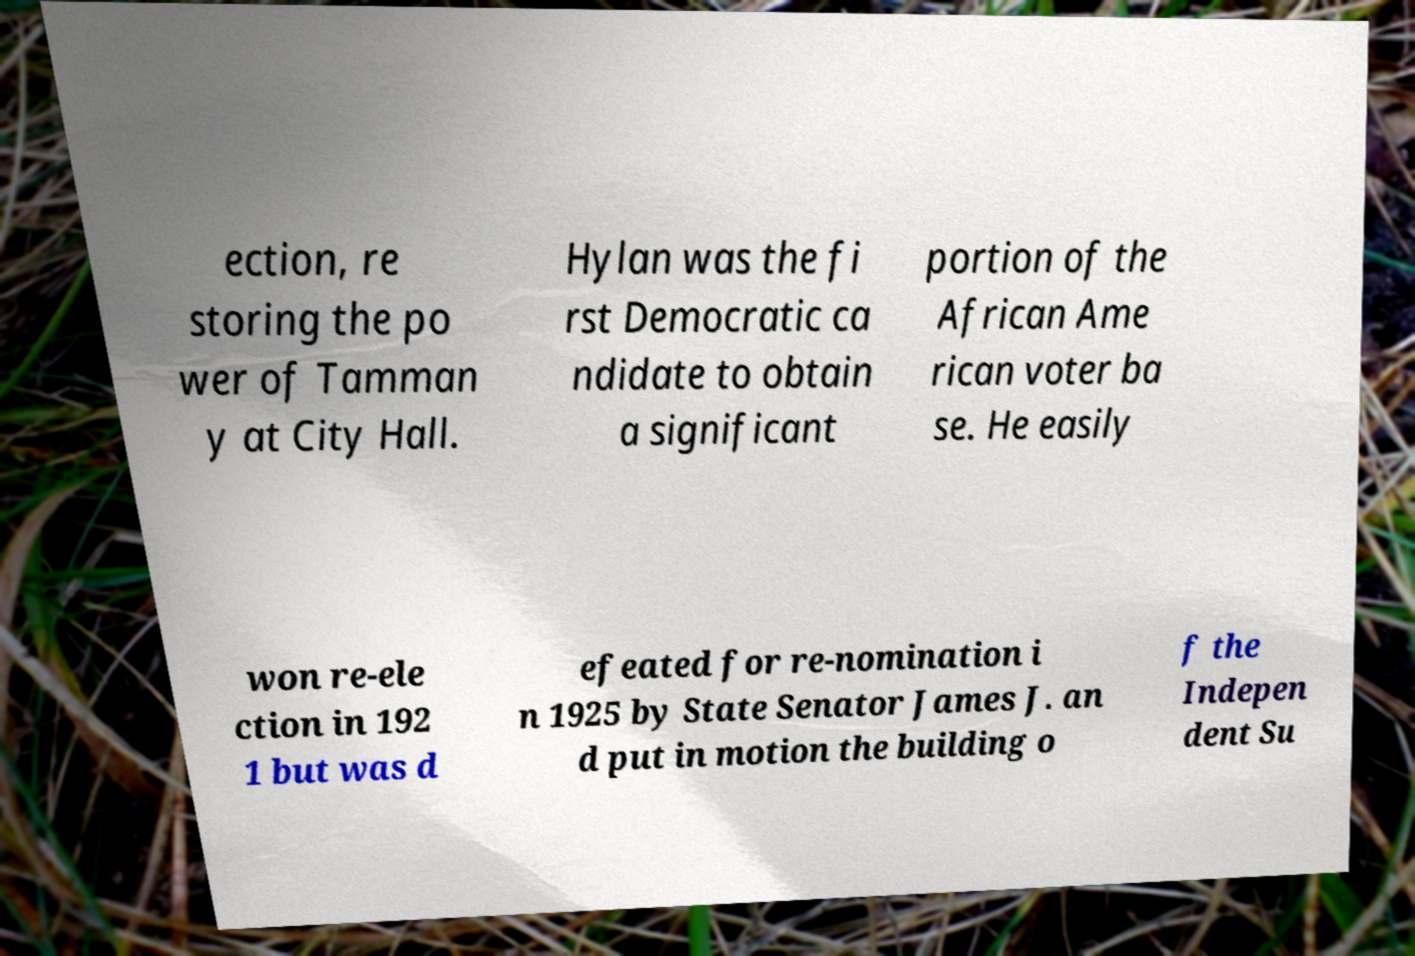Could you assist in decoding the text presented in this image and type it out clearly? ection, re storing the po wer of Tamman y at City Hall. Hylan was the fi rst Democratic ca ndidate to obtain a significant portion of the African Ame rican voter ba se. He easily won re-ele ction in 192 1 but was d efeated for re-nomination i n 1925 by State Senator James J. an d put in motion the building o f the Indepen dent Su 